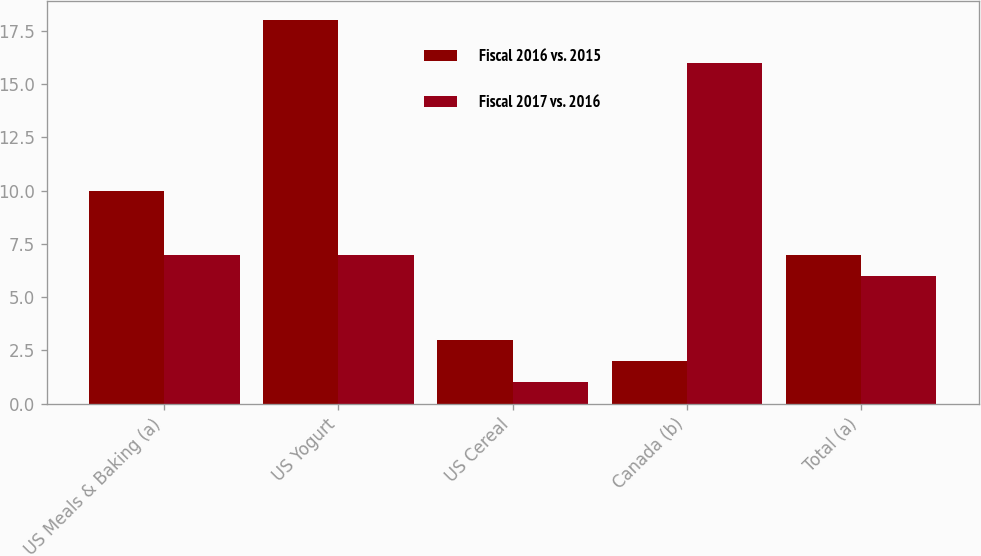<chart> <loc_0><loc_0><loc_500><loc_500><stacked_bar_chart><ecel><fcel>US Meals & Baking (a)<fcel>US Yogurt<fcel>US Cereal<fcel>Canada (b)<fcel>Total (a)<nl><fcel>Fiscal 2016 vs. 2015<fcel>10<fcel>18<fcel>3<fcel>2<fcel>7<nl><fcel>Fiscal 2017 vs. 2016<fcel>7<fcel>7<fcel>1<fcel>16<fcel>6<nl></chart> 